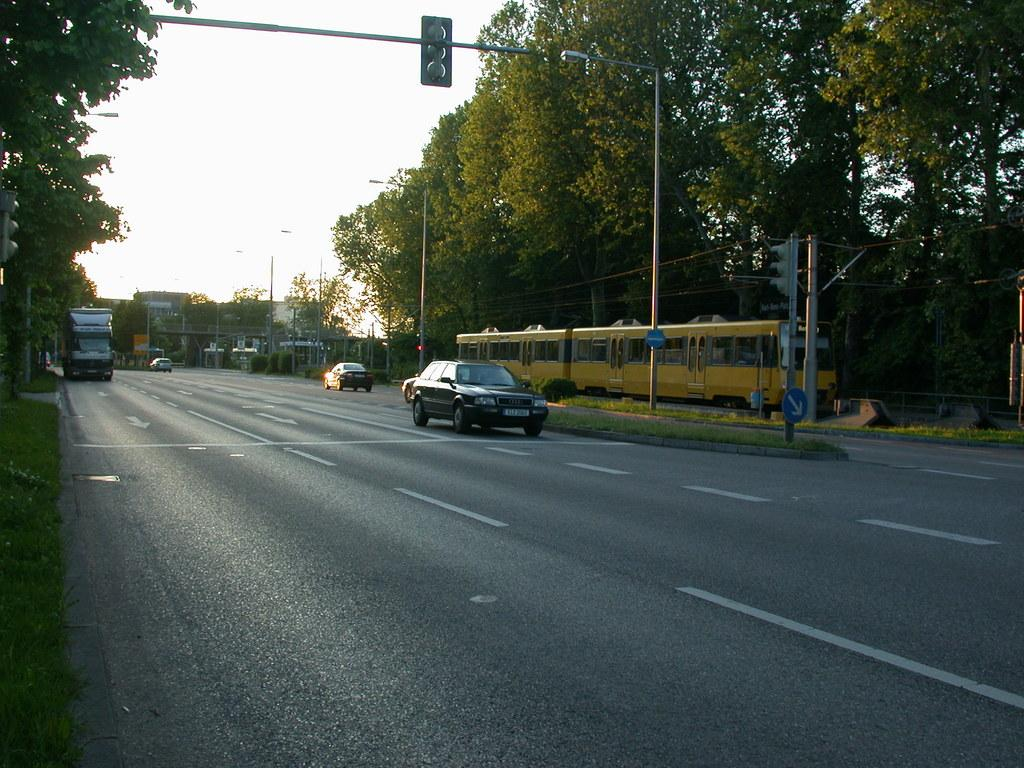What is the main subject of the image? The main subject of the image is a car moving on the road. What can be seen at the top of the image? There is a traffic signal at the top of the image. What type of vegetation is on the right side of the image? There are trees on the right side of the image. How much honey is being used by the car in the image? There is no honey present in the image; it features a car moving on the road and a traffic signal. What type of ground is the car rolling on in the image? The image does not show the ground beneath the car; it only shows the car moving on the road. 